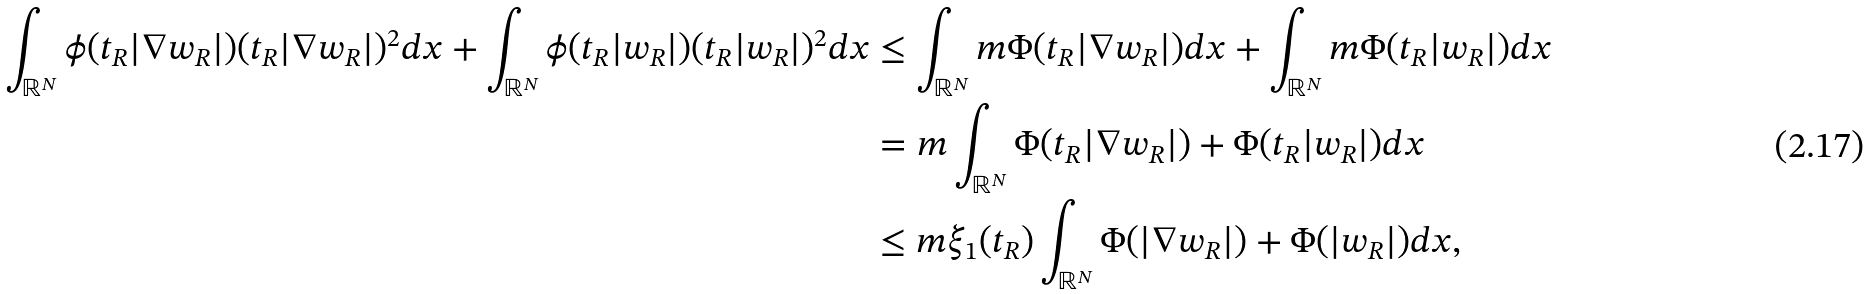<formula> <loc_0><loc_0><loc_500><loc_500>\int _ { \mathbb { R } ^ { N } } \phi ( t _ { R } | \nabla w _ { R } | ) ( t _ { R } | \nabla w _ { R } | ) ^ { 2 } d x + \int _ { \mathbb { R } ^ { N } } \phi ( t _ { R } | w _ { R } | ) ( t _ { R } | w _ { R } | ) ^ { 2 } d x & \leq \int _ { \mathbb { R } ^ { N } } m \Phi ( t _ { R } | \nabla w _ { R } | ) d x + \int _ { \mathbb { R } ^ { N } } m \Phi ( t _ { R } | w _ { R } | ) d x \\ & = m \int _ { \mathbb { R } ^ { N } } \Phi ( t _ { R } | \nabla w _ { R } | ) + \Phi ( t _ { R } | w _ { R } | ) d x \\ & \leq m \xi _ { 1 } ( t _ { R } ) \int _ { \mathbb { R } ^ { N } } \Phi ( | \nabla w _ { R } | ) + \Phi ( | w _ { R } | ) d x ,</formula> 